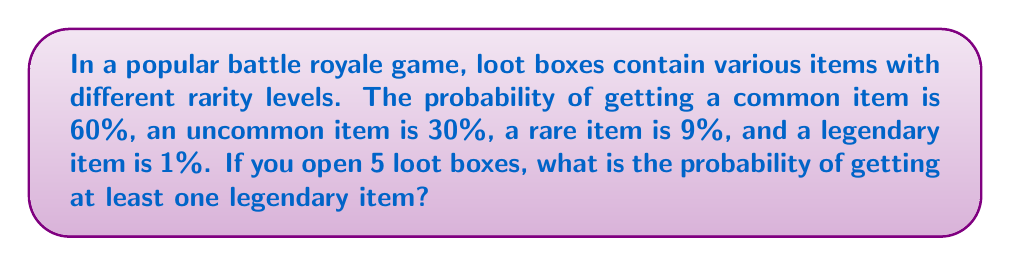Give your solution to this math problem. Let's approach this step-by-step:

1) First, we need to find the probability of not getting a legendary item in a single loot box. This is:
   $1 - 0.01 = 0.99$ or $99\%$

2) Now, we need to calculate the probability of not getting a legendary item in all 5 loot boxes. This is:
   $(0.99)^5$

3) To find the probability of getting at least one legendary item, we need to subtract this from 1:
   $1 - (0.99)^5$

4) Let's calculate this:
   $1 - (0.99)^5 = 1 - 0.9509775 = 0.0490225$

5) Converting to a percentage:
   $0.0490225 \times 100\% = 4.90225\%$

Therefore, the probability of getting at least one legendary item when opening 5 loot boxes is approximately 4.90%.
Answer: $4.90\%$ 